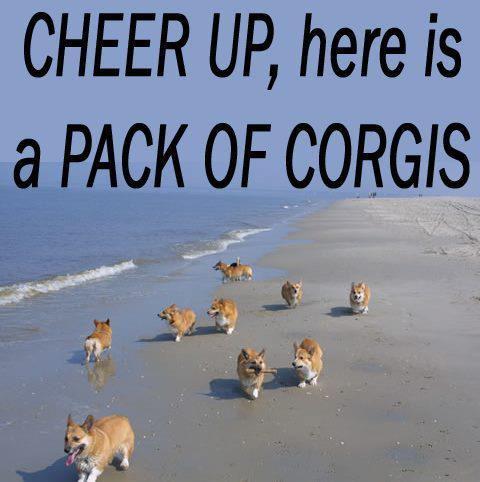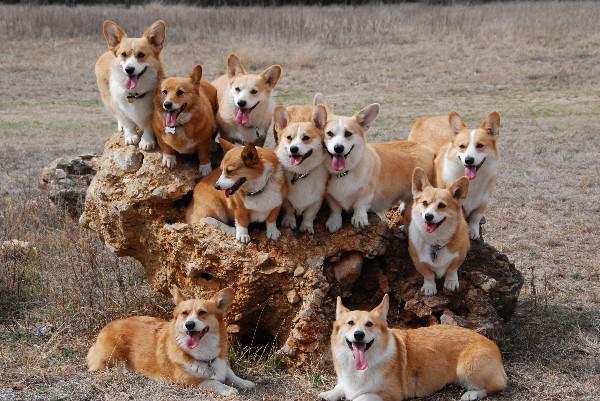The first image is the image on the left, the second image is the image on the right. Considering the images on both sides, is "There are no more than 7 dogs in total." valid? Answer yes or no. No. 